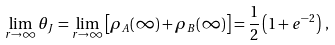Convert formula to latex. <formula><loc_0><loc_0><loc_500><loc_500>\lim _ { r \rightarrow \infty } \theta _ { J } = \lim _ { r \rightarrow \infty } \left [ \rho _ { A } ( \infty ) + \rho _ { B } ( \infty ) \right ] = \frac { 1 } { 2 } \left ( 1 + e ^ { - 2 } \right ) \, ,</formula> 